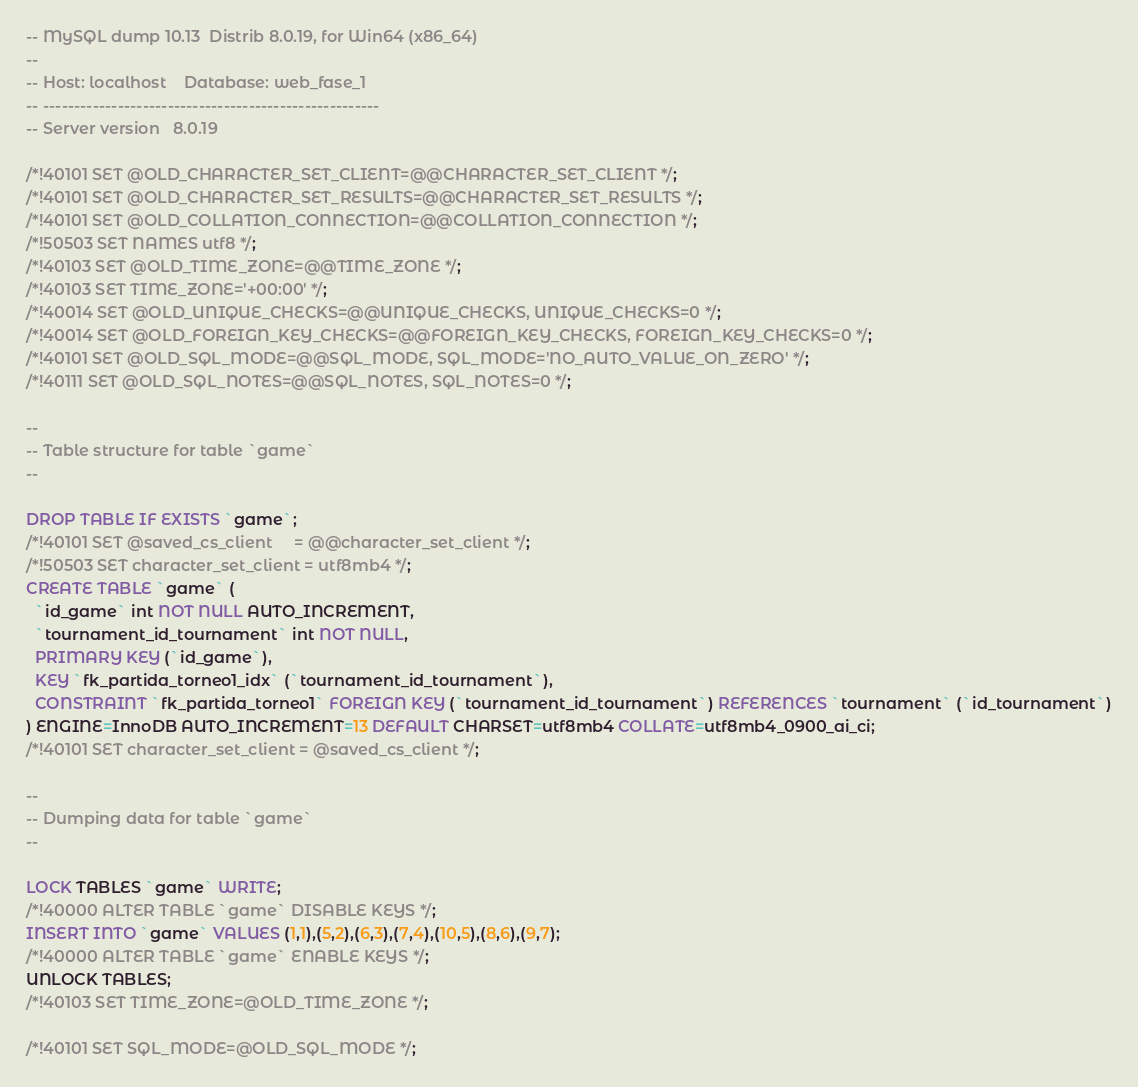<code> <loc_0><loc_0><loc_500><loc_500><_SQL_>-- MySQL dump 10.13  Distrib 8.0.19, for Win64 (x86_64)
--
-- Host: localhost    Database: web_fase_1
-- ------------------------------------------------------
-- Server version	8.0.19

/*!40101 SET @OLD_CHARACTER_SET_CLIENT=@@CHARACTER_SET_CLIENT */;
/*!40101 SET @OLD_CHARACTER_SET_RESULTS=@@CHARACTER_SET_RESULTS */;
/*!40101 SET @OLD_COLLATION_CONNECTION=@@COLLATION_CONNECTION */;
/*!50503 SET NAMES utf8 */;
/*!40103 SET @OLD_TIME_ZONE=@@TIME_ZONE */;
/*!40103 SET TIME_ZONE='+00:00' */;
/*!40014 SET @OLD_UNIQUE_CHECKS=@@UNIQUE_CHECKS, UNIQUE_CHECKS=0 */;
/*!40014 SET @OLD_FOREIGN_KEY_CHECKS=@@FOREIGN_KEY_CHECKS, FOREIGN_KEY_CHECKS=0 */;
/*!40101 SET @OLD_SQL_MODE=@@SQL_MODE, SQL_MODE='NO_AUTO_VALUE_ON_ZERO' */;
/*!40111 SET @OLD_SQL_NOTES=@@SQL_NOTES, SQL_NOTES=0 */;

--
-- Table structure for table `game`
--

DROP TABLE IF EXISTS `game`;
/*!40101 SET @saved_cs_client     = @@character_set_client */;
/*!50503 SET character_set_client = utf8mb4 */;
CREATE TABLE `game` (
  `id_game` int NOT NULL AUTO_INCREMENT,
  `tournament_id_tournament` int NOT NULL,
  PRIMARY KEY (`id_game`),
  KEY `fk_partida_torneo1_idx` (`tournament_id_tournament`),
  CONSTRAINT `fk_partida_torneo1` FOREIGN KEY (`tournament_id_tournament`) REFERENCES `tournament` (`id_tournament`)
) ENGINE=InnoDB AUTO_INCREMENT=13 DEFAULT CHARSET=utf8mb4 COLLATE=utf8mb4_0900_ai_ci;
/*!40101 SET character_set_client = @saved_cs_client */;

--
-- Dumping data for table `game`
--

LOCK TABLES `game` WRITE;
/*!40000 ALTER TABLE `game` DISABLE KEYS */;
INSERT INTO `game` VALUES (1,1),(5,2),(6,3),(7,4),(10,5),(8,6),(9,7);
/*!40000 ALTER TABLE `game` ENABLE KEYS */;
UNLOCK TABLES;
/*!40103 SET TIME_ZONE=@OLD_TIME_ZONE */;

/*!40101 SET SQL_MODE=@OLD_SQL_MODE */;</code> 